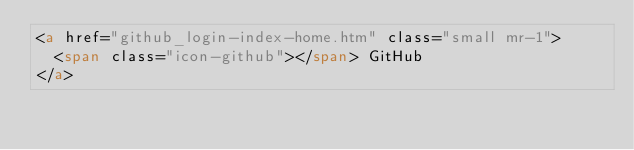<code> <loc_0><loc_0><loc_500><loc_500><_HTML_><a href="github_login-index-home.htm" class="small mr-1">
	<span class="icon-github"></span> GitHub
</a>
</code> 